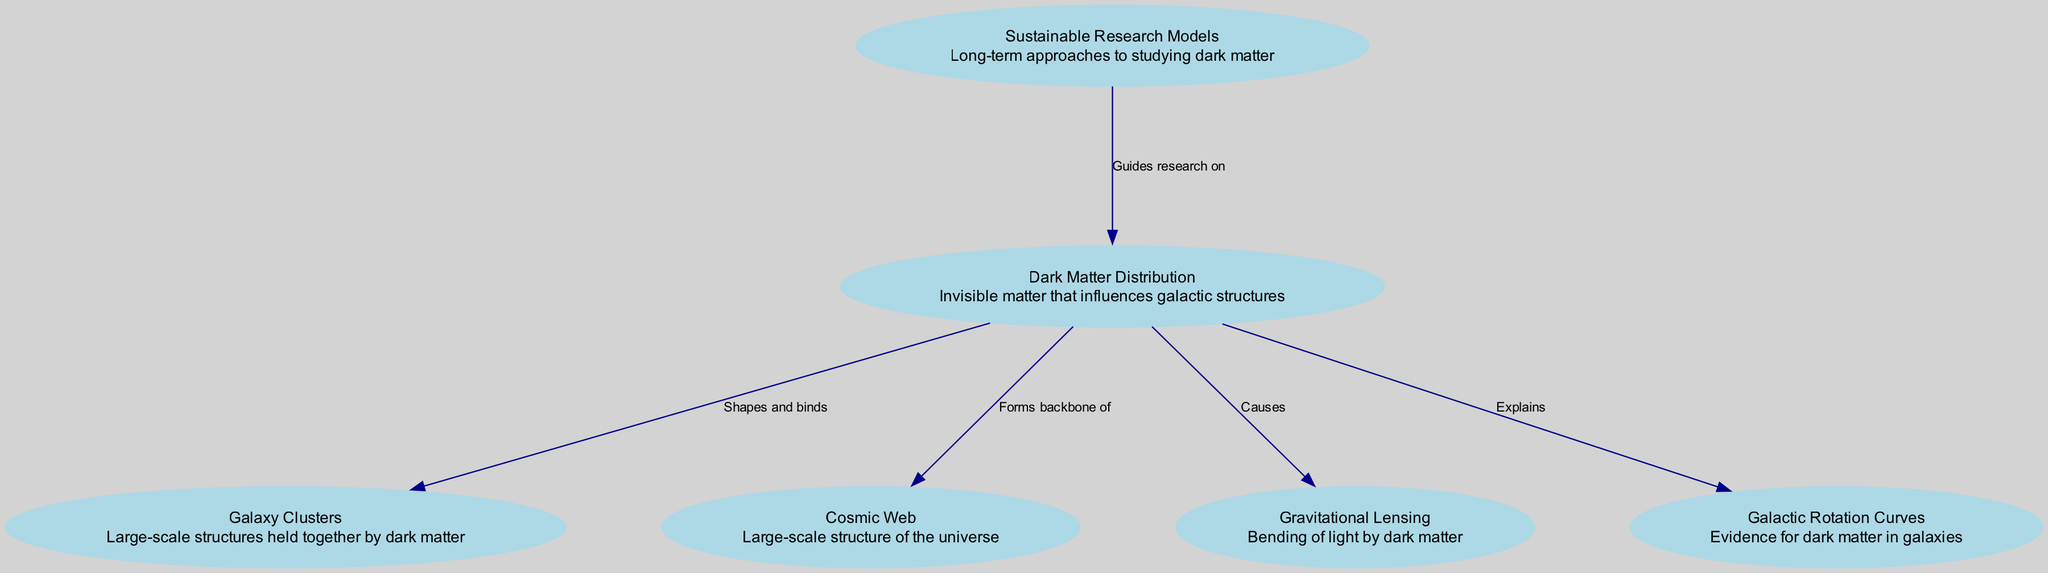What does the dark matter distribution influence in the universe? According to the diagram, dark matter distribution influences galaxy clusters. The edge connecting "dark_matter" to "galaxy_clusters" is labeled "Shapes and binds," indicating this influence.
Answer: Galaxy Clusters How many nodes are present in the diagram? By counting the entries marked as nodes in the data, we find there are six distinct nodes: dark matter, galaxy clusters, cosmic web, gravitational lensing, galactic rotation, and sustainable research models.
Answer: Six What is the role of dark matter in gravitational lensing? The diagram indicates that dark matter causes gravitational lensing, as shown by the edge labeled "Causes" connecting "dark_matter" to "gravitational_lensing."
Answer: Causes What backbone structure does dark matter form in the universe? The edge labeled "Forms backbone of" connects dark matter to the cosmic web, signifying that dark matter provides this foundational aspect to the structure of the universe.
Answer: Cosmic Web Which research models guide studies on dark matter? The diagram implies that sustainable research models guide research on dark matter. This is indicated by the edge pointing from "sustainable_models" to "dark_matter," confirming this relationship.
Answer: Sustainable Research Models How does dark matter explain galactic rotation? The relationship is depicted in the diagram where dark matter is linked to galactic rotation curves through an edge labeled "Explains," suggesting that dark matter plays a crucial role in understanding these curves.
Answer: Explains 